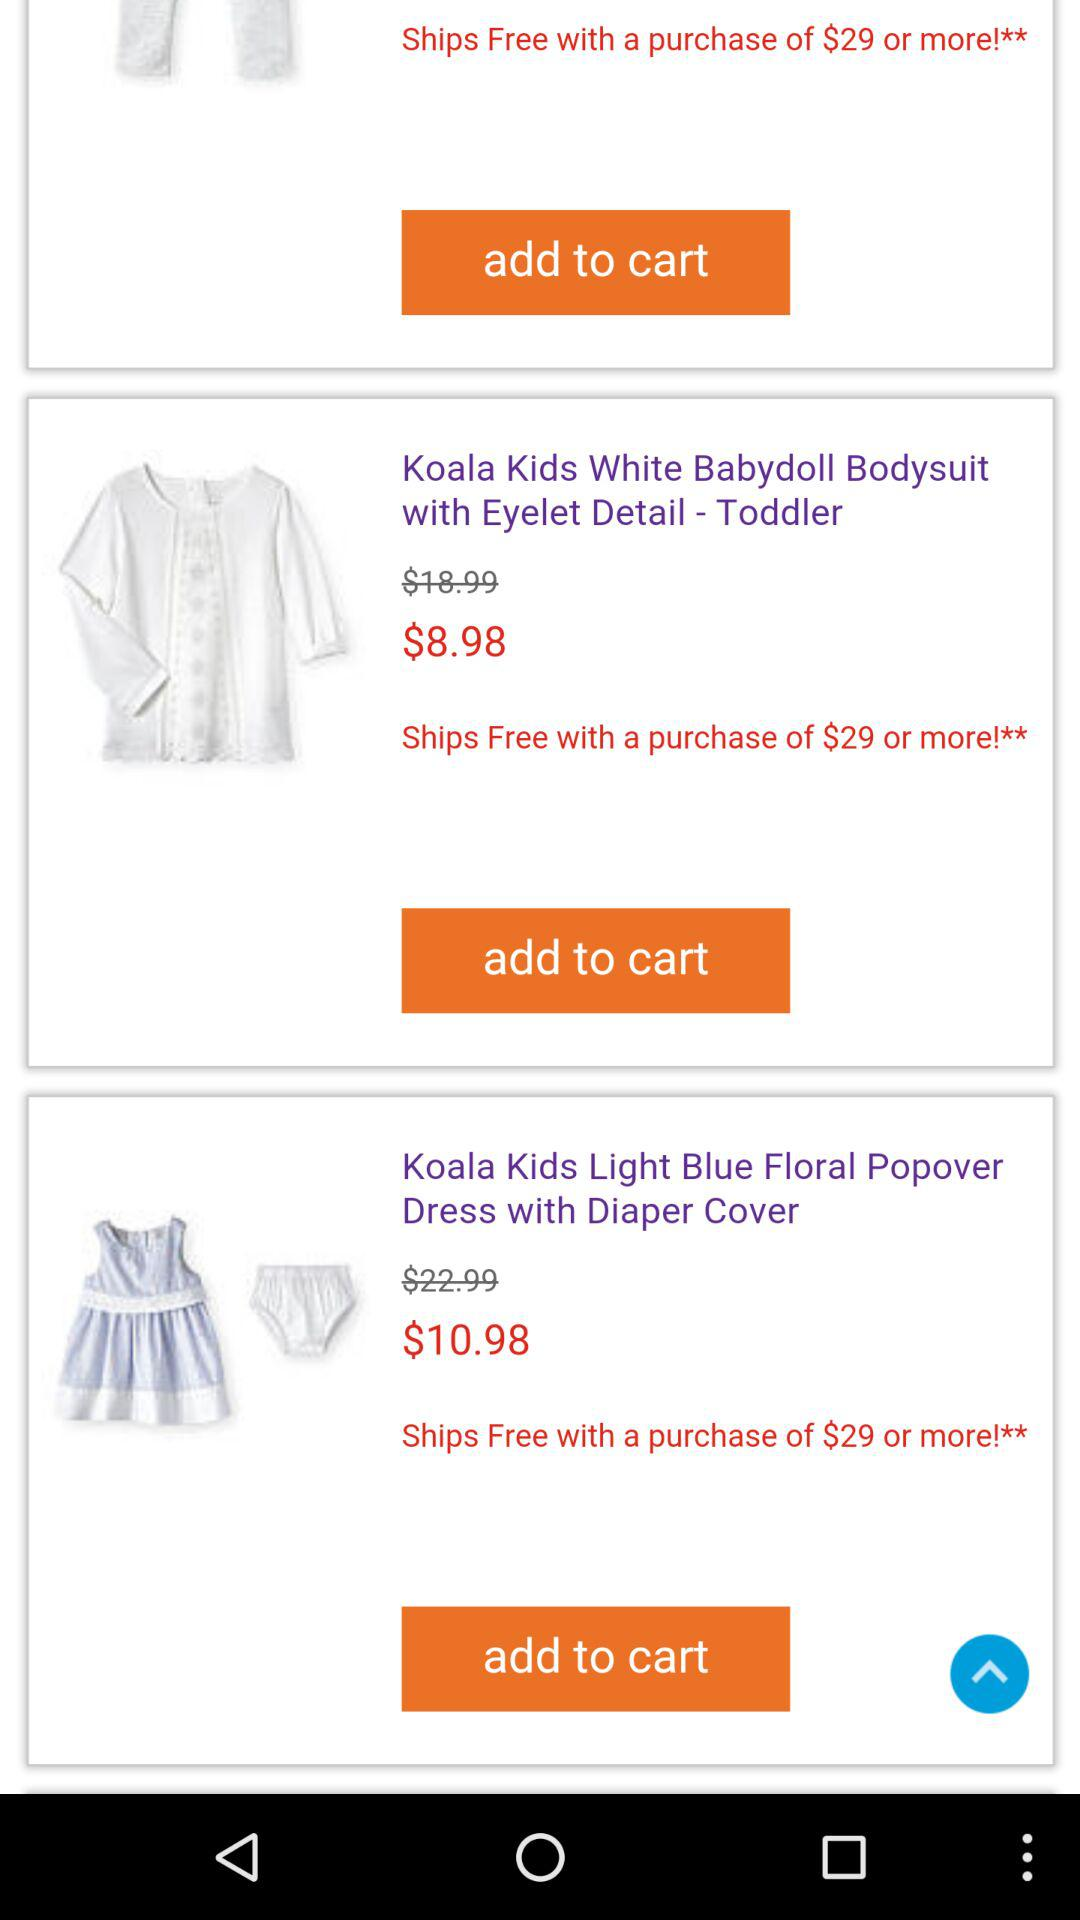Which dress has a price of $10.98? The dress that has a price of $10.98 is "Koala Kids Light Blue Floral Popover Dress with Diaper Cover". 